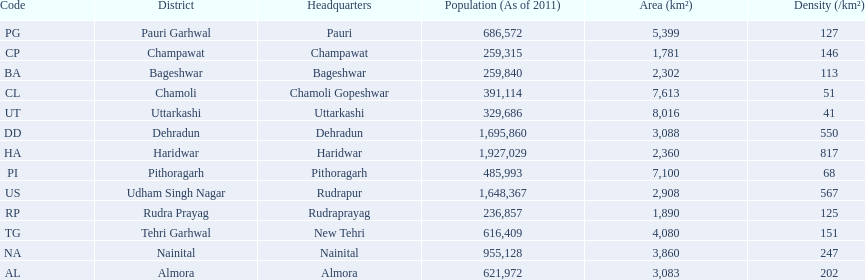What are the values for density of the districts of uttrakhand? 202, 113, 51, 146, 550, 817, 247, 127, 68, 125, 151, 567, 41. Which district has value of 51? Chamoli. 